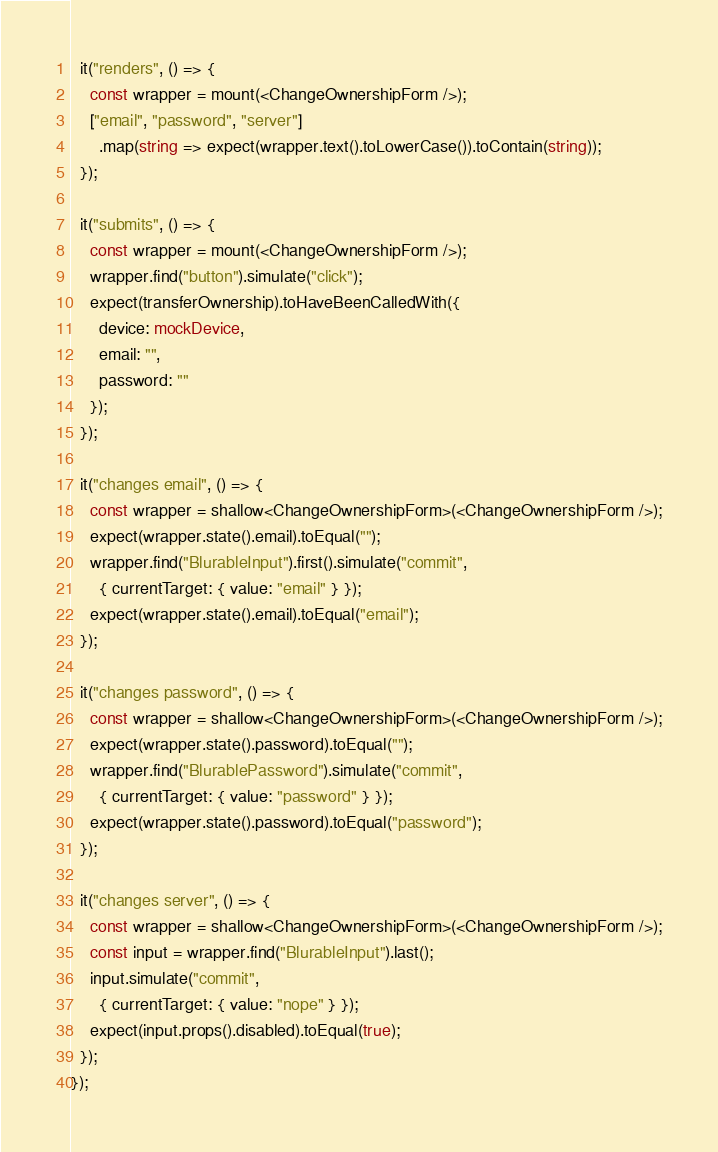Convert code to text. <code><loc_0><loc_0><loc_500><loc_500><_TypeScript_>
  it("renders", () => {
    const wrapper = mount(<ChangeOwnershipForm />);
    ["email", "password", "server"]
      .map(string => expect(wrapper.text().toLowerCase()).toContain(string));
  });

  it("submits", () => {
    const wrapper = mount(<ChangeOwnershipForm />);
    wrapper.find("button").simulate("click");
    expect(transferOwnership).toHaveBeenCalledWith({
      device: mockDevice,
      email: "",
      password: ""
    });
  });

  it("changes email", () => {
    const wrapper = shallow<ChangeOwnershipForm>(<ChangeOwnershipForm />);
    expect(wrapper.state().email).toEqual("");
    wrapper.find("BlurableInput").first().simulate("commit",
      { currentTarget: { value: "email" } });
    expect(wrapper.state().email).toEqual("email");
  });

  it("changes password", () => {
    const wrapper = shallow<ChangeOwnershipForm>(<ChangeOwnershipForm />);
    expect(wrapper.state().password).toEqual("");
    wrapper.find("BlurablePassword").simulate("commit",
      { currentTarget: { value: "password" } });
    expect(wrapper.state().password).toEqual("password");
  });

  it("changes server", () => {
    const wrapper = shallow<ChangeOwnershipForm>(<ChangeOwnershipForm />);
    const input = wrapper.find("BlurableInput").last();
    input.simulate("commit",
      { currentTarget: { value: "nope" } });
    expect(input.props().disabled).toEqual(true);
  });
});
</code> 